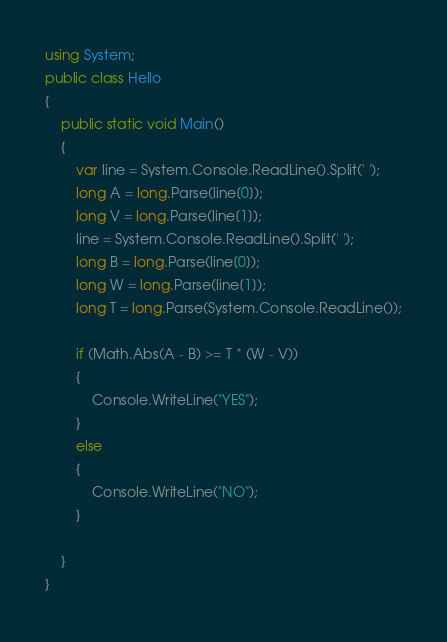<code> <loc_0><loc_0><loc_500><loc_500><_C#_>using System;
public class Hello
{
    public static void Main()
    {
        var line = System.Console.ReadLine().Split(' ');
        long A = long.Parse(line[0]);
        long V = long.Parse(line[1]);
        line = System.Console.ReadLine().Split(' ');
        long B = long.Parse(line[0]);
        long W = long.Parse(line[1]);
        long T = long.Parse(System.Console.ReadLine());

        if (Math.Abs(A - B) >= T * (W - V))
        {
            Console.WriteLine("YES");
        }
        else
        {
            Console.WriteLine("NO");
        }
        
    }
}
</code> 